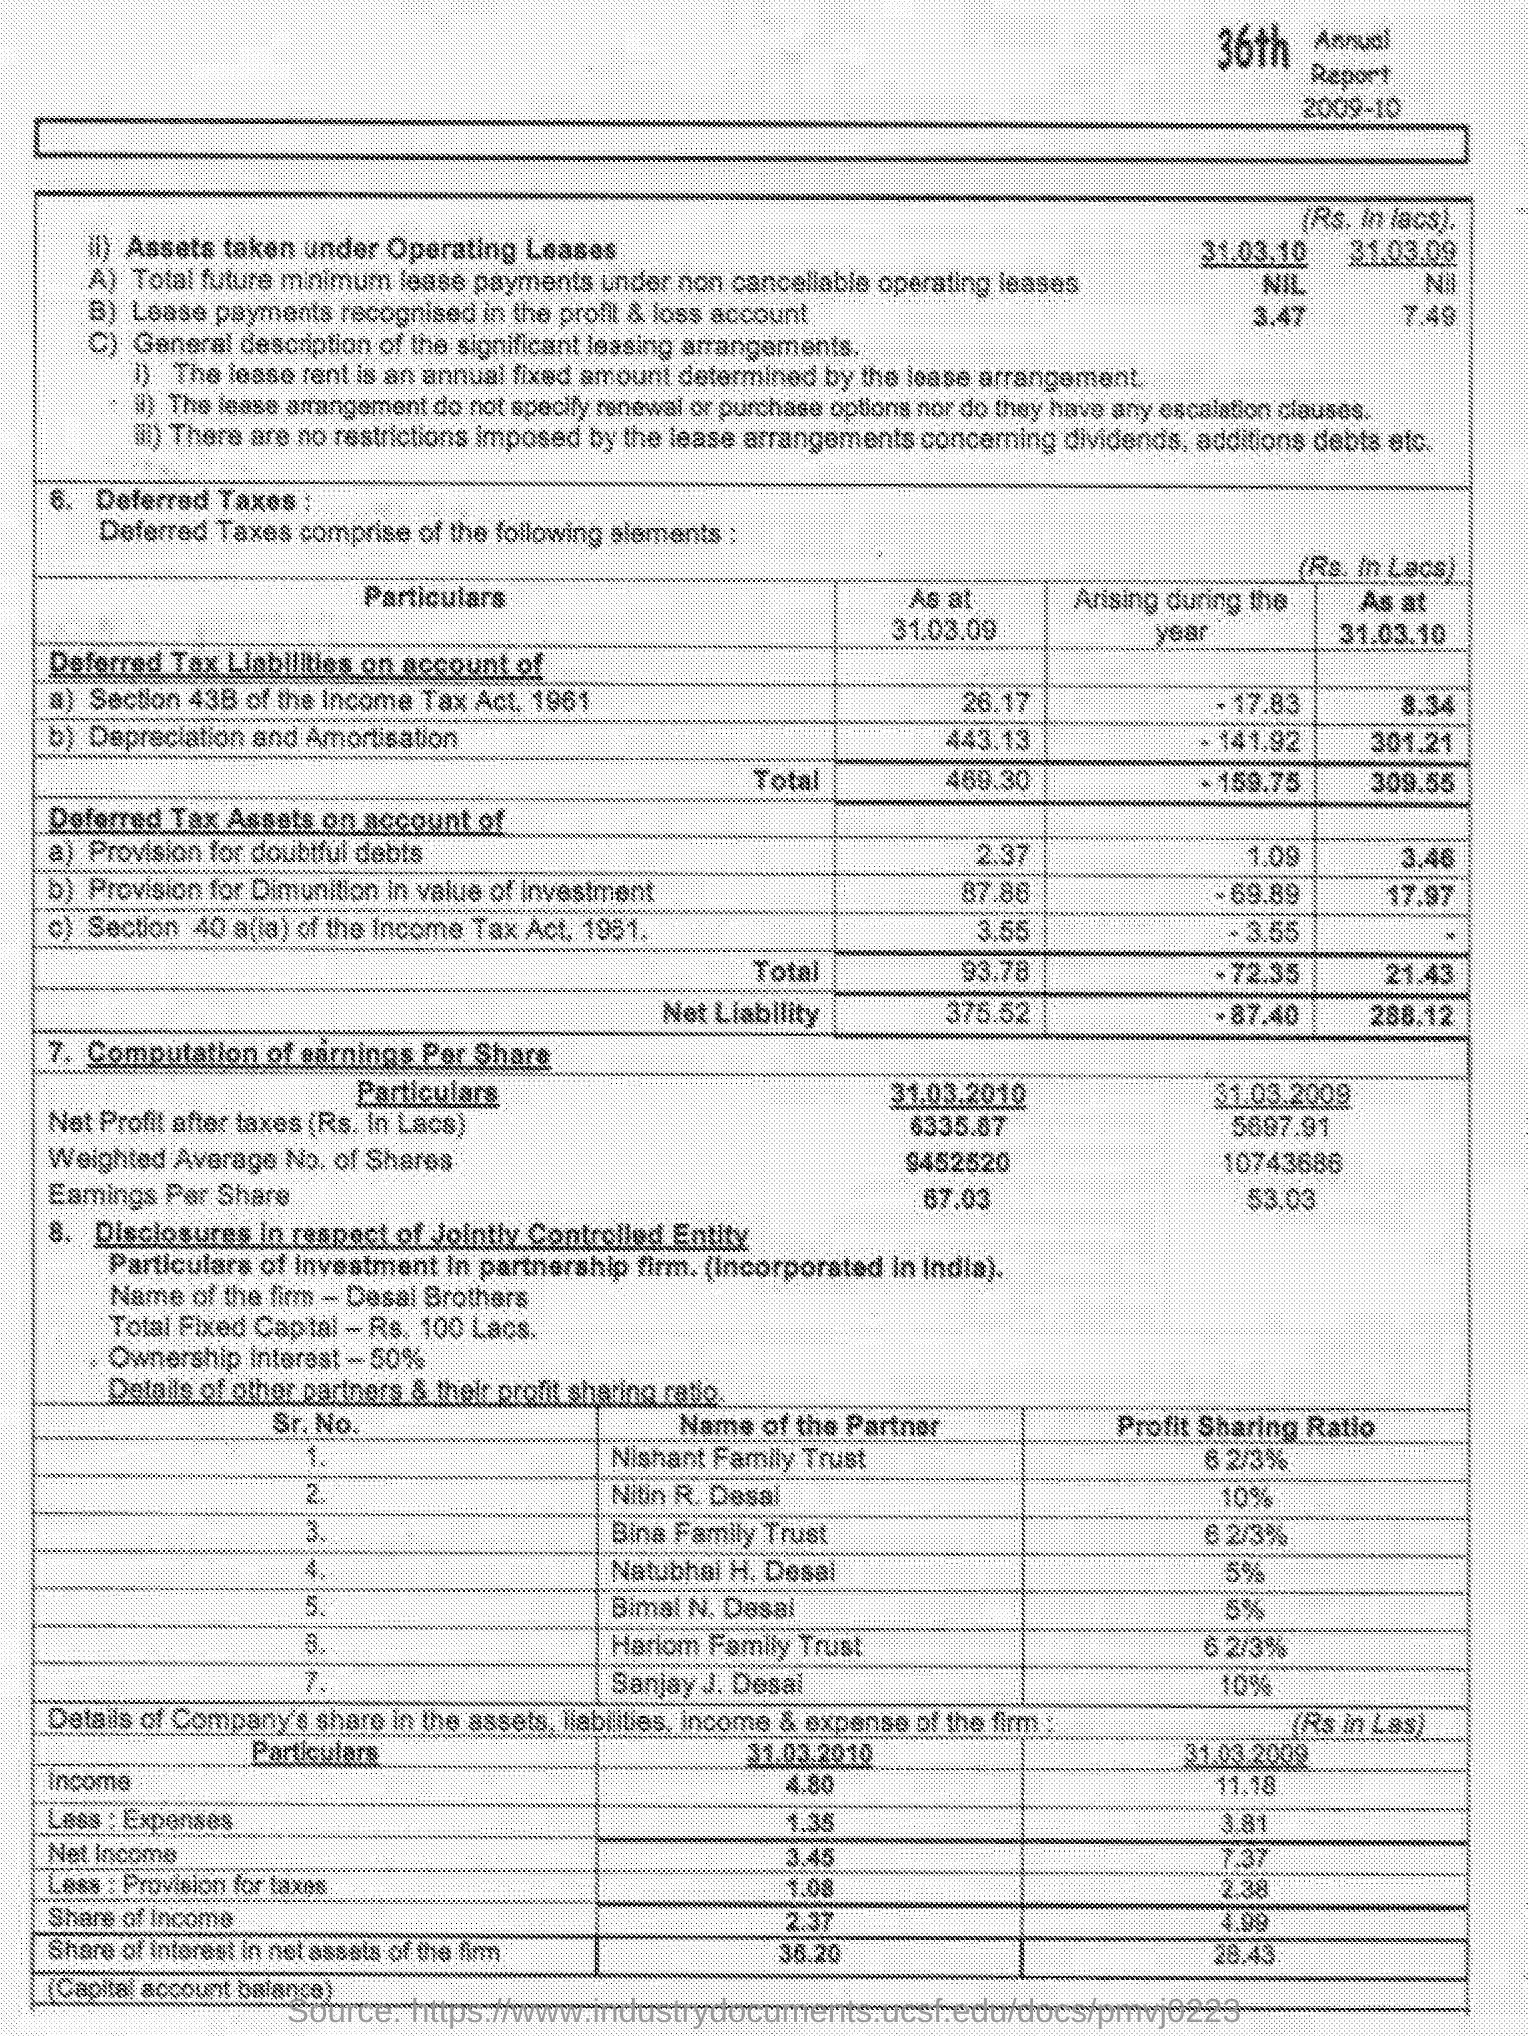Specify some key components in this picture. The ownership interest is 50%. The profit-sharing ratio of Sanjay J. Desai is 10%. The total fixed capital is Rs. 100 Lacs. Desai Brothers is the name of the firm. The profit-sharing ratio of Nitin R. Desai is 10%. 